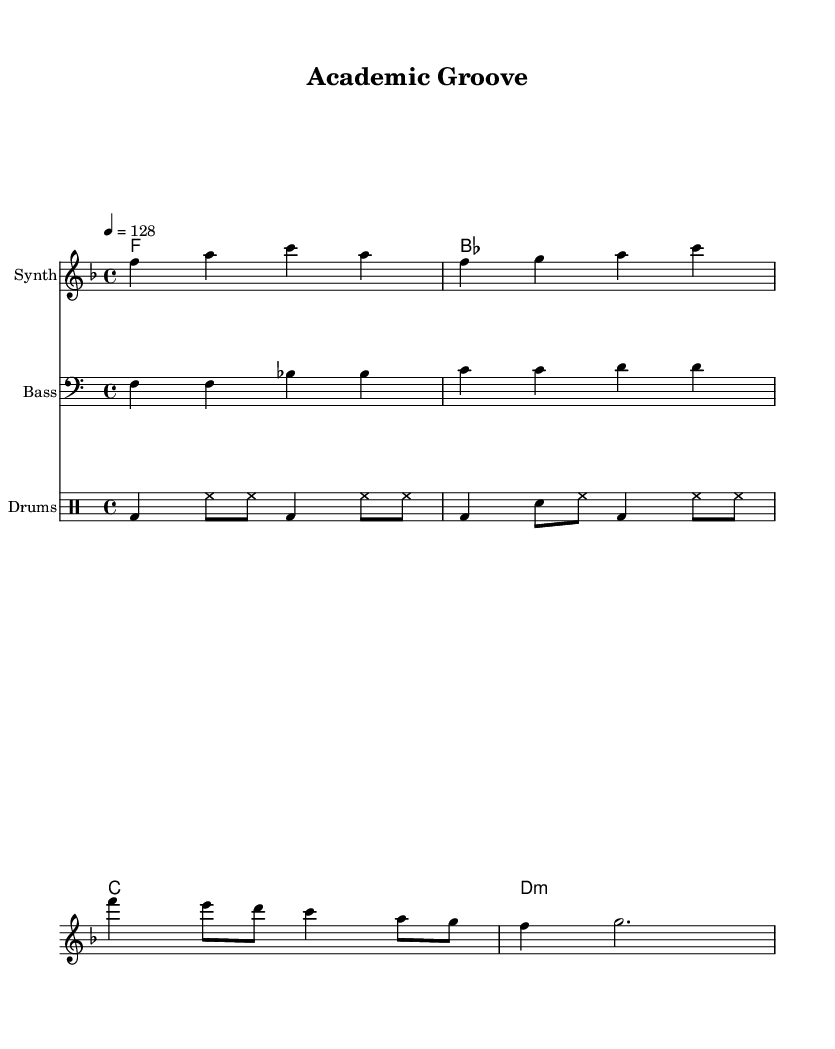What is the key signature of this music? The key signature is F major, which is indicated by one flat (B).
Answer: F major What is the time signature of this piece? The time signature is 4/4, indicated through the notation at the beginning of the score.
Answer: 4/4 What is the tempo of the piece? The tempo is indicated as 128 beats per minute, specified at the beginning of the score.
Answer: 128 What is the harmony progression used in this piece? The harmony progression consists of F, B-flat, C, and D minor chords, as shown in the chord names section.
Answer: F, B-flat, C, D minor How many measures are there in the melody? The melody consists of four measures, which can be counted by the vertical bar lines separating each measure.
Answer: 4 What type of drum pattern is used in this music? The drum pattern consists of a bass drum (bd), hi-hat (hh), and snare drum (sn), which are typical elements found in house music.
Answer: Bass and hi-hat What style of music is this piece associated with? This sheet music is associated with funky disco-inspired house music, evident from the upbeat tempo and rhythmic elements.
Answer: House 